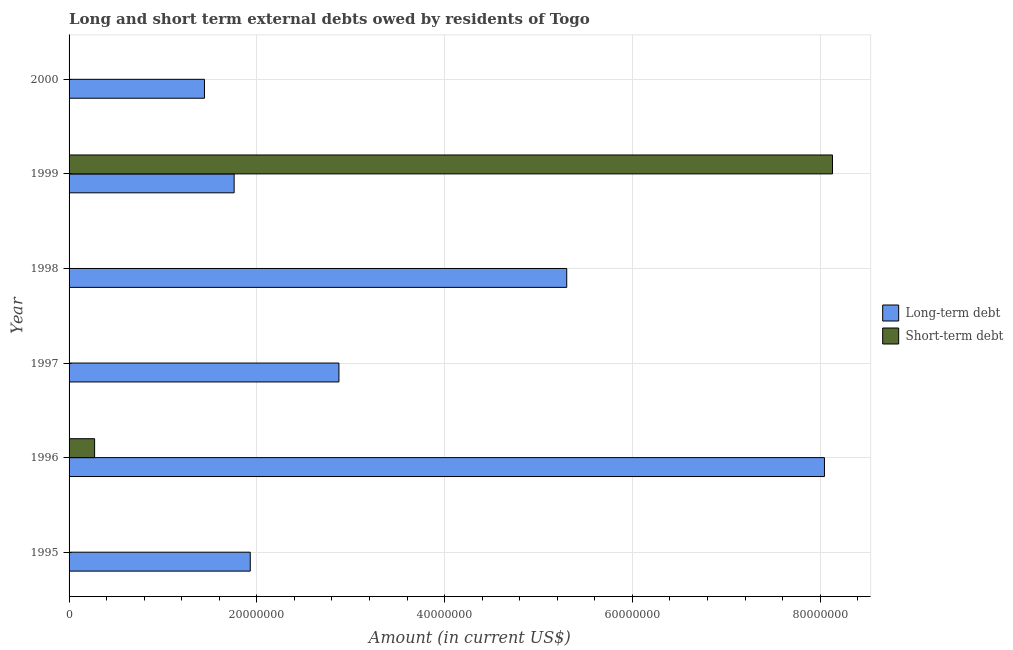How many different coloured bars are there?
Provide a short and direct response. 2. What is the long-term debts owed by residents in 1995?
Your response must be concise. 1.93e+07. Across all years, what is the maximum short-term debts owed by residents?
Keep it short and to the point. 8.13e+07. What is the total long-term debts owed by residents in the graph?
Make the answer very short. 2.14e+08. What is the difference between the long-term debts owed by residents in 1997 and that in 1998?
Give a very brief answer. -2.43e+07. What is the difference between the short-term debts owed by residents in 1997 and the long-term debts owed by residents in 1996?
Your answer should be compact. -8.05e+07. What is the average long-term debts owed by residents per year?
Provide a short and direct response. 3.56e+07. In the year 1999, what is the difference between the long-term debts owed by residents and short-term debts owed by residents?
Provide a succinct answer. -6.37e+07. In how many years, is the long-term debts owed by residents greater than 64000000 US$?
Provide a succinct answer. 1. What is the ratio of the long-term debts owed by residents in 1997 to that in 1999?
Ensure brevity in your answer.  1.64. Is the long-term debts owed by residents in 1999 less than that in 2000?
Provide a short and direct response. No. What is the difference between the highest and the second highest long-term debts owed by residents?
Your answer should be compact. 2.74e+07. What is the difference between the highest and the lowest short-term debts owed by residents?
Provide a short and direct response. 8.13e+07. How many bars are there?
Provide a short and direct response. 8. Are all the bars in the graph horizontal?
Your answer should be compact. Yes. How many years are there in the graph?
Your answer should be very brief. 6. Are the values on the major ticks of X-axis written in scientific E-notation?
Your answer should be compact. No. Does the graph contain grids?
Your response must be concise. Yes. What is the title of the graph?
Your answer should be compact. Long and short term external debts owed by residents of Togo. What is the Amount (in current US$) of Long-term debt in 1995?
Make the answer very short. 1.93e+07. What is the Amount (in current US$) of Short-term debt in 1995?
Make the answer very short. 0. What is the Amount (in current US$) in Long-term debt in 1996?
Make the answer very short. 8.05e+07. What is the Amount (in current US$) in Short-term debt in 1996?
Give a very brief answer. 2.72e+06. What is the Amount (in current US$) of Long-term debt in 1997?
Your answer should be compact. 2.87e+07. What is the Amount (in current US$) of Long-term debt in 1998?
Provide a succinct answer. 5.30e+07. What is the Amount (in current US$) of Short-term debt in 1998?
Keep it short and to the point. 0. What is the Amount (in current US$) of Long-term debt in 1999?
Offer a terse response. 1.76e+07. What is the Amount (in current US$) in Short-term debt in 1999?
Give a very brief answer. 8.13e+07. What is the Amount (in current US$) in Long-term debt in 2000?
Keep it short and to the point. 1.44e+07. Across all years, what is the maximum Amount (in current US$) of Long-term debt?
Make the answer very short. 8.05e+07. Across all years, what is the maximum Amount (in current US$) of Short-term debt?
Make the answer very short. 8.13e+07. Across all years, what is the minimum Amount (in current US$) in Long-term debt?
Provide a short and direct response. 1.44e+07. What is the total Amount (in current US$) of Long-term debt in the graph?
Keep it short and to the point. 2.14e+08. What is the total Amount (in current US$) in Short-term debt in the graph?
Offer a terse response. 8.40e+07. What is the difference between the Amount (in current US$) of Long-term debt in 1995 and that in 1996?
Your answer should be very brief. -6.12e+07. What is the difference between the Amount (in current US$) in Long-term debt in 1995 and that in 1997?
Ensure brevity in your answer.  -9.44e+06. What is the difference between the Amount (in current US$) in Long-term debt in 1995 and that in 1998?
Give a very brief answer. -3.37e+07. What is the difference between the Amount (in current US$) in Long-term debt in 1995 and that in 1999?
Keep it short and to the point. 1.72e+06. What is the difference between the Amount (in current US$) of Long-term debt in 1995 and that in 2000?
Your answer should be compact. 4.88e+06. What is the difference between the Amount (in current US$) in Long-term debt in 1996 and that in 1997?
Give a very brief answer. 5.17e+07. What is the difference between the Amount (in current US$) of Long-term debt in 1996 and that in 1998?
Make the answer very short. 2.74e+07. What is the difference between the Amount (in current US$) of Long-term debt in 1996 and that in 1999?
Give a very brief answer. 6.29e+07. What is the difference between the Amount (in current US$) in Short-term debt in 1996 and that in 1999?
Keep it short and to the point. -7.86e+07. What is the difference between the Amount (in current US$) in Long-term debt in 1996 and that in 2000?
Make the answer very short. 6.60e+07. What is the difference between the Amount (in current US$) of Long-term debt in 1997 and that in 1998?
Your response must be concise. -2.43e+07. What is the difference between the Amount (in current US$) of Long-term debt in 1997 and that in 1999?
Give a very brief answer. 1.12e+07. What is the difference between the Amount (in current US$) in Long-term debt in 1997 and that in 2000?
Your answer should be very brief. 1.43e+07. What is the difference between the Amount (in current US$) of Long-term debt in 1998 and that in 1999?
Your answer should be compact. 3.54e+07. What is the difference between the Amount (in current US$) of Long-term debt in 1998 and that in 2000?
Keep it short and to the point. 3.86e+07. What is the difference between the Amount (in current US$) of Long-term debt in 1999 and that in 2000?
Provide a short and direct response. 3.16e+06. What is the difference between the Amount (in current US$) in Long-term debt in 1995 and the Amount (in current US$) in Short-term debt in 1996?
Make the answer very short. 1.66e+07. What is the difference between the Amount (in current US$) in Long-term debt in 1995 and the Amount (in current US$) in Short-term debt in 1999?
Offer a terse response. -6.20e+07. What is the difference between the Amount (in current US$) of Long-term debt in 1996 and the Amount (in current US$) of Short-term debt in 1999?
Your answer should be compact. -8.56e+05. What is the difference between the Amount (in current US$) in Long-term debt in 1997 and the Amount (in current US$) in Short-term debt in 1999?
Provide a succinct answer. -5.26e+07. What is the difference between the Amount (in current US$) of Long-term debt in 1998 and the Amount (in current US$) of Short-term debt in 1999?
Provide a short and direct response. -2.83e+07. What is the average Amount (in current US$) in Long-term debt per year?
Keep it short and to the point. 3.56e+07. What is the average Amount (in current US$) in Short-term debt per year?
Provide a succinct answer. 1.40e+07. In the year 1996, what is the difference between the Amount (in current US$) in Long-term debt and Amount (in current US$) in Short-term debt?
Your answer should be very brief. 7.77e+07. In the year 1999, what is the difference between the Amount (in current US$) of Long-term debt and Amount (in current US$) of Short-term debt?
Provide a succinct answer. -6.37e+07. What is the ratio of the Amount (in current US$) of Long-term debt in 1995 to that in 1996?
Your response must be concise. 0.24. What is the ratio of the Amount (in current US$) in Long-term debt in 1995 to that in 1997?
Your answer should be very brief. 0.67. What is the ratio of the Amount (in current US$) in Long-term debt in 1995 to that in 1998?
Your answer should be very brief. 0.36. What is the ratio of the Amount (in current US$) of Long-term debt in 1995 to that in 1999?
Offer a very short reply. 1.1. What is the ratio of the Amount (in current US$) in Long-term debt in 1995 to that in 2000?
Your response must be concise. 1.34. What is the ratio of the Amount (in current US$) in Long-term debt in 1996 to that in 1997?
Your answer should be compact. 2.8. What is the ratio of the Amount (in current US$) of Long-term debt in 1996 to that in 1998?
Give a very brief answer. 1.52. What is the ratio of the Amount (in current US$) of Long-term debt in 1996 to that in 1999?
Your answer should be compact. 4.58. What is the ratio of the Amount (in current US$) in Short-term debt in 1996 to that in 1999?
Provide a succinct answer. 0.03. What is the ratio of the Amount (in current US$) of Long-term debt in 1996 to that in 2000?
Give a very brief answer. 5.58. What is the ratio of the Amount (in current US$) in Long-term debt in 1997 to that in 1998?
Your response must be concise. 0.54. What is the ratio of the Amount (in current US$) of Long-term debt in 1997 to that in 1999?
Keep it short and to the point. 1.63. What is the ratio of the Amount (in current US$) of Long-term debt in 1997 to that in 2000?
Your answer should be compact. 1.99. What is the ratio of the Amount (in current US$) of Long-term debt in 1998 to that in 1999?
Keep it short and to the point. 3.01. What is the ratio of the Amount (in current US$) in Long-term debt in 1998 to that in 2000?
Your response must be concise. 3.68. What is the ratio of the Amount (in current US$) of Long-term debt in 1999 to that in 2000?
Your answer should be compact. 1.22. What is the difference between the highest and the second highest Amount (in current US$) in Long-term debt?
Give a very brief answer. 2.74e+07. What is the difference between the highest and the lowest Amount (in current US$) in Long-term debt?
Your answer should be compact. 6.60e+07. What is the difference between the highest and the lowest Amount (in current US$) in Short-term debt?
Your response must be concise. 8.13e+07. 